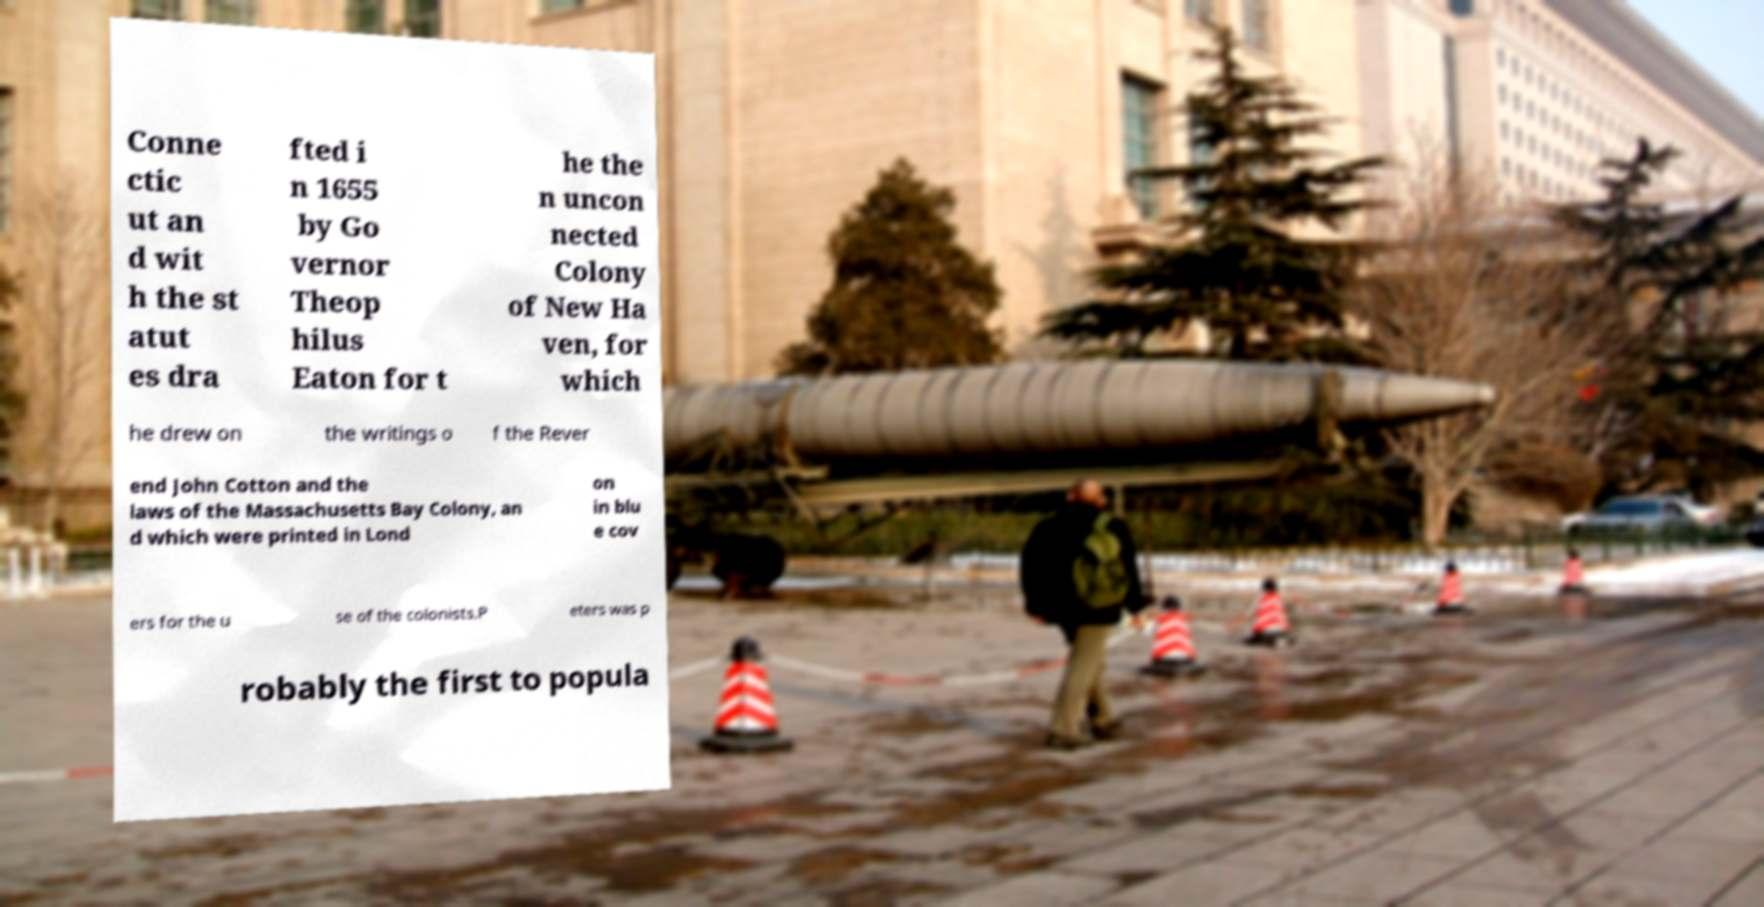Please identify and transcribe the text found in this image. Conne ctic ut an d wit h the st atut es dra fted i n 1655 by Go vernor Theop hilus Eaton for t he the n uncon nected Colony of New Ha ven, for which he drew on the writings o f the Rever end John Cotton and the laws of the Massachusetts Bay Colony, an d which were printed in Lond on in blu e cov ers for the u se of the colonists.P eters was p robably the first to popula 